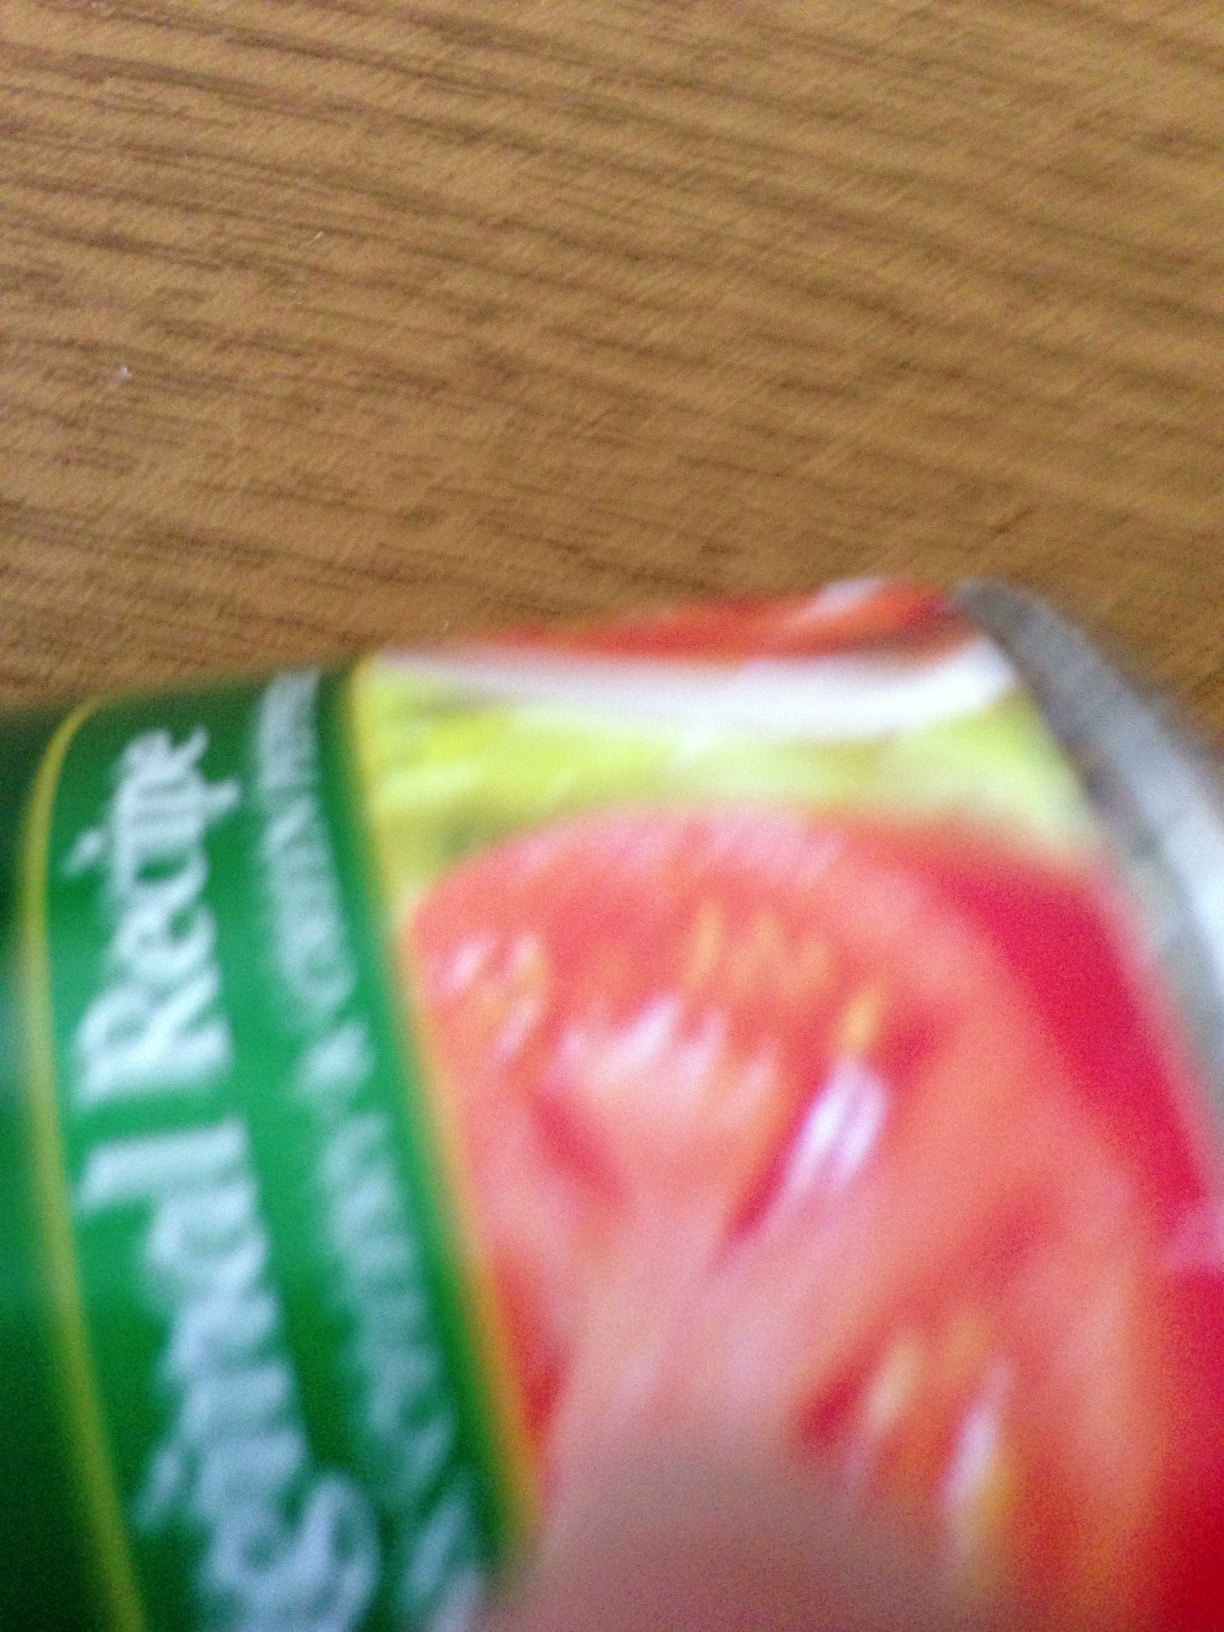What type of product do you think this is based on its partial visibility? Even though it's quite blurred, the green and red colors as well as the visible word fragments suggest it might be a kind of food product, possibly packaged fresh produce like tomatoes. That's interesting! What kind of retail settings would typically carry such items? Grocery stores, supermarkets, and possibly local farmers' markets are typical retail settings where fresh food items like vegetables or packaged produce are often found. 